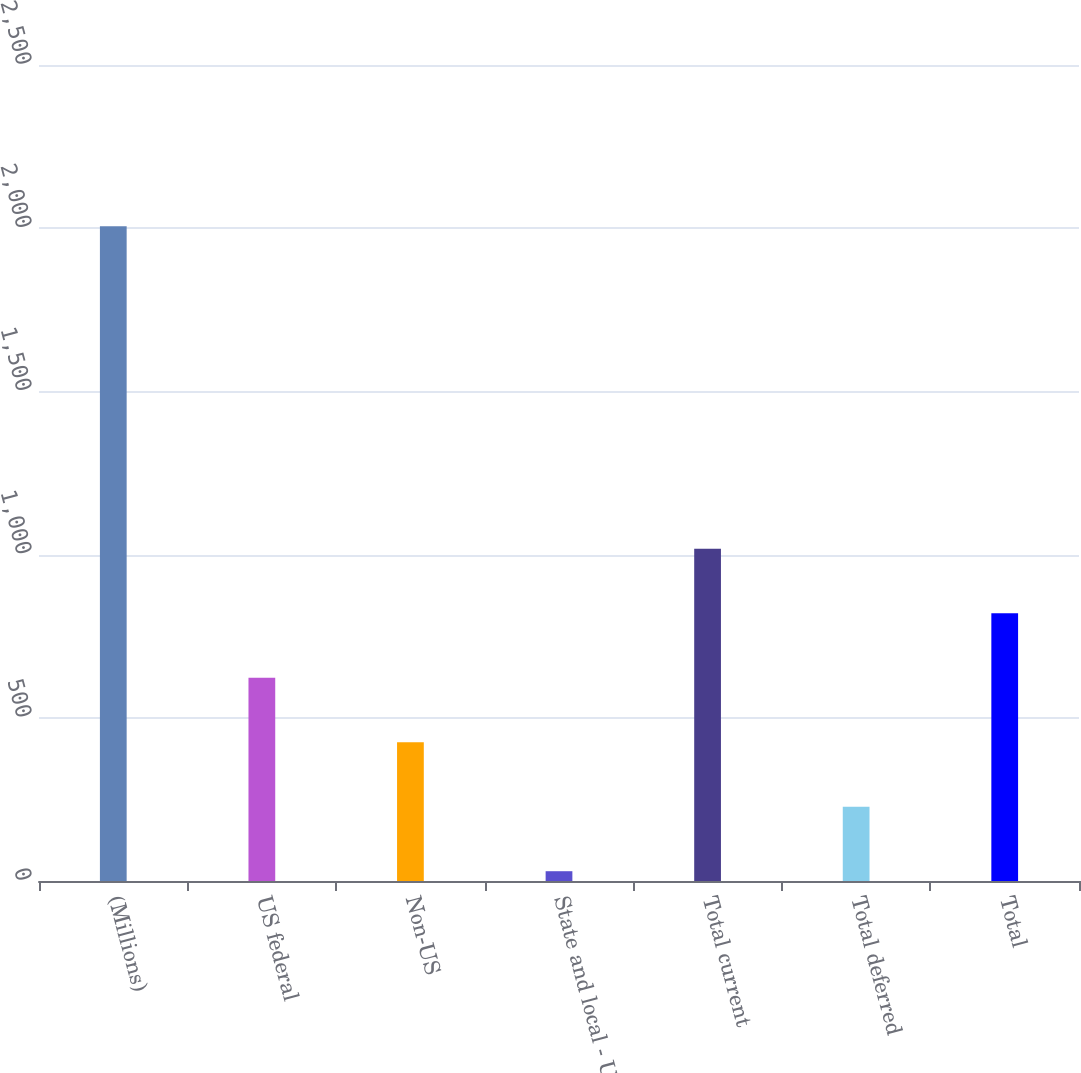<chart> <loc_0><loc_0><loc_500><loc_500><bar_chart><fcel>(Millions)<fcel>US federal<fcel>Non-US<fcel>State and local - US<fcel>Total current<fcel>Total deferred<fcel>Total<nl><fcel>2006<fcel>622.8<fcel>425.2<fcel>30<fcel>1018<fcel>227.6<fcel>820.4<nl></chart> 